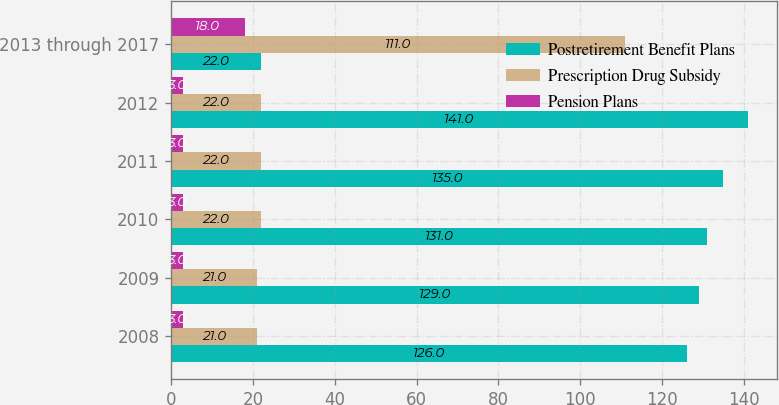Convert chart to OTSL. <chart><loc_0><loc_0><loc_500><loc_500><stacked_bar_chart><ecel><fcel>2008<fcel>2009<fcel>2010<fcel>2011<fcel>2012<fcel>2013 through 2017<nl><fcel>Postretirement Benefit Plans<fcel>126<fcel>129<fcel>131<fcel>135<fcel>141<fcel>22<nl><fcel>Prescription Drug Subsidy<fcel>21<fcel>21<fcel>22<fcel>22<fcel>22<fcel>111<nl><fcel>Pension Plans<fcel>3<fcel>3<fcel>3<fcel>3<fcel>3<fcel>18<nl></chart> 